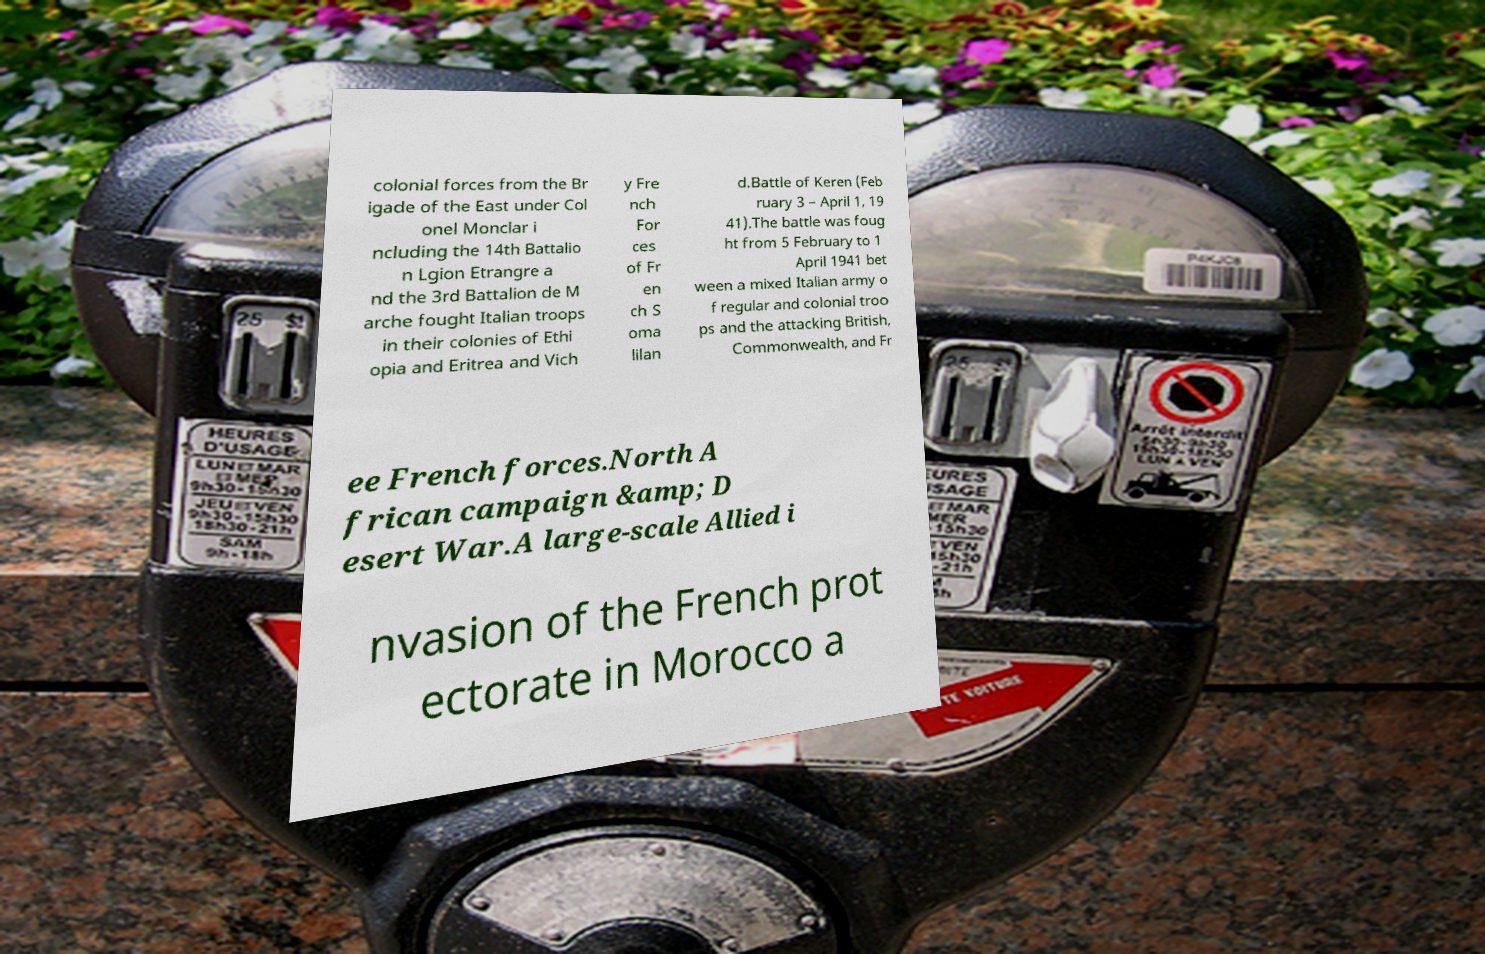There's text embedded in this image that I need extracted. Can you transcribe it verbatim? colonial forces from the Br igade of the East under Col onel Monclar i ncluding the 14th Battalio n Lgion Etrangre a nd the 3rd Battalion de M arche fought Italian troops in their colonies of Ethi opia and Eritrea and Vich y Fre nch For ces of Fr en ch S oma lilan d.Battle of Keren (Feb ruary 3 – April 1, 19 41).The battle was foug ht from 5 February to 1 April 1941 bet ween a mixed Italian army o f regular and colonial troo ps and the attacking British, Commonwealth, and Fr ee French forces.North A frican campaign &amp; D esert War.A large-scale Allied i nvasion of the French prot ectorate in Morocco a 